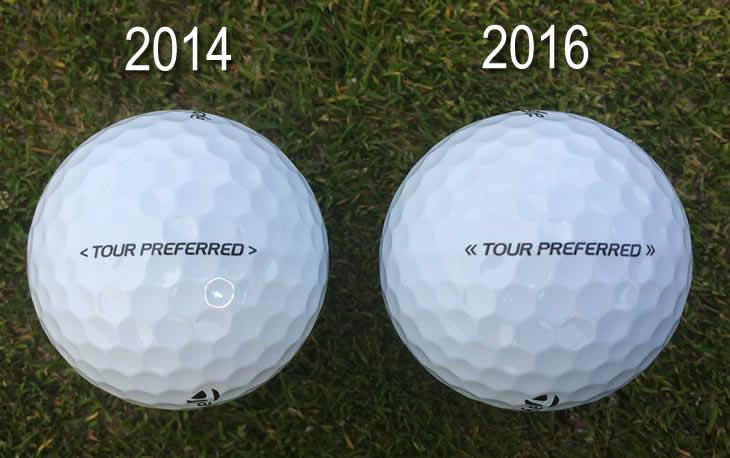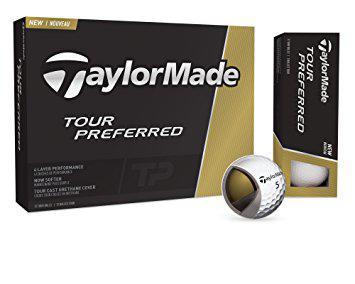The first image is the image on the left, the second image is the image on the right. Evaluate the accuracy of this statement regarding the images: "All golf balls are in boxes, a total of at least nine boxes of balls are shown, and some boxes have hexagon 'windows' at the center.". Is it true? Answer yes or no. No. The first image is the image on the left, the second image is the image on the right. Considering the images on both sides, is "All the golf balls are in boxes." valid? Answer yes or no. No. 